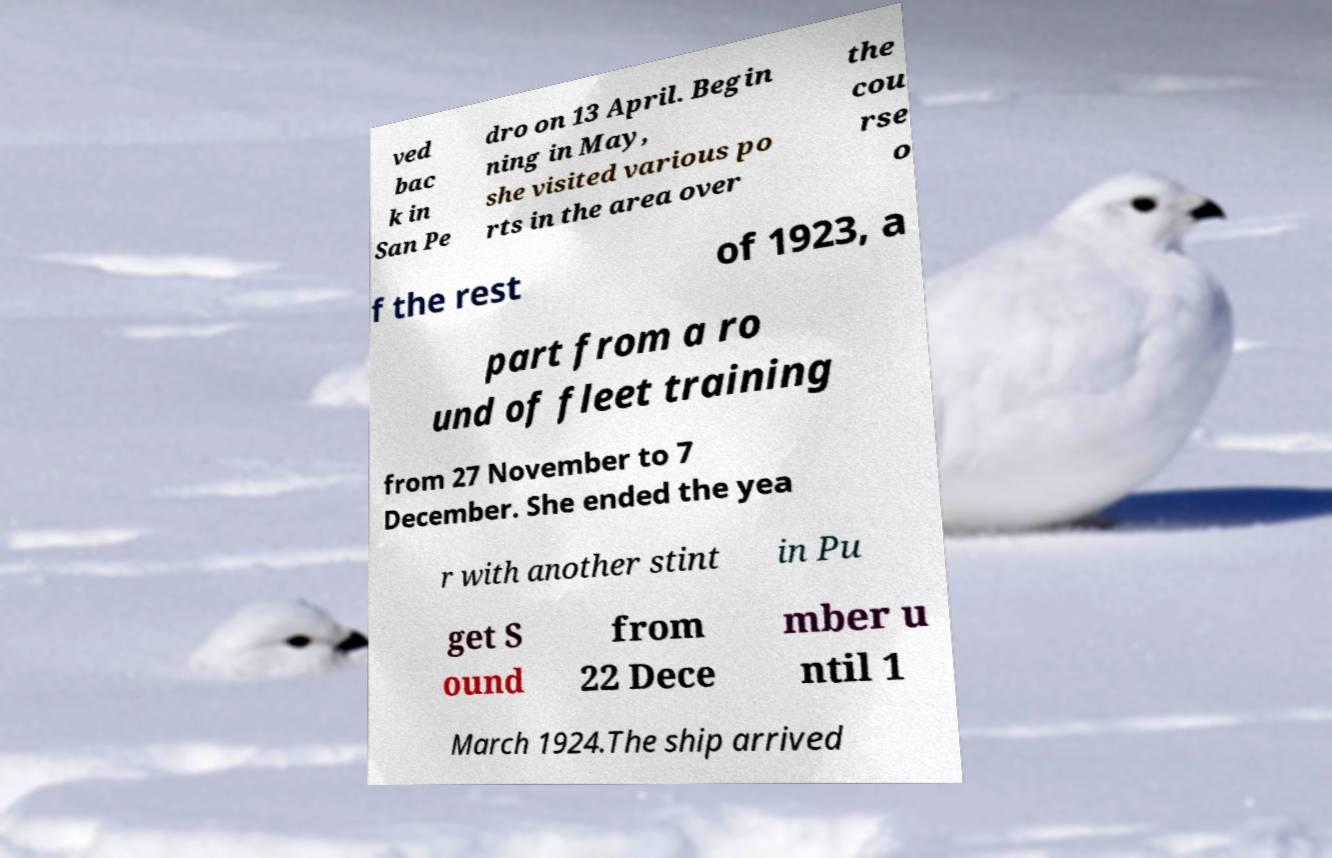I need the written content from this picture converted into text. Can you do that? ved bac k in San Pe dro on 13 April. Begin ning in May, she visited various po rts in the area over the cou rse o f the rest of 1923, a part from a ro und of fleet training from 27 November to 7 December. She ended the yea r with another stint in Pu get S ound from 22 Dece mber u ntil 1 March 1924.The ship arrived 